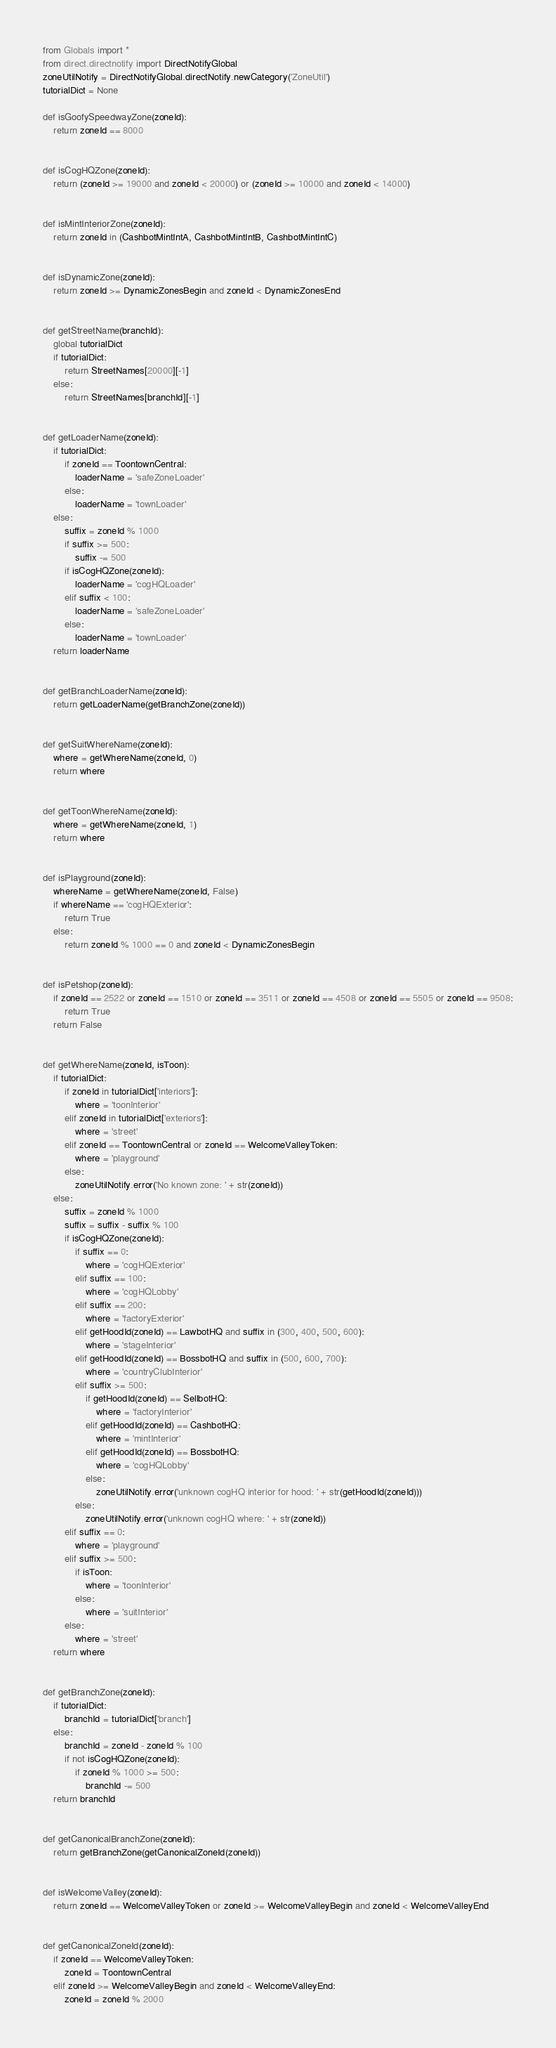Convert code to text. <code><loc_0><loc_0><loc_500><loc_500><_Python_>from Globals import *
from direct.directnotify import DirectNotifyGlobal
zoneUtilNotify = DirectNotifyGlobal.directNotify.newCategory('ZoneUtil')
tutorialDict = None

def isGoofySpeedwayZone(zoneId):
    return zoneId == 8000


def isCogHQZone(zoneId):
    return (zoneId >= 19000 and zoneId < 20000) or (zoneId >= 10000 and zoneId < 14000)


def isMintInteriorZone(zoneId):
    return zoneId in (CashbotMintIntA, CashbotMintIntB, CashbotMintIntC)


def isDynamicZone(zoneId):
    return zoneId >= DynamicZonesBegin and zoneId < DynamicZonesEnd


def getStreetName(branchId):
    global tutorialDict
    if tutorialDict:
        return StreetNames[20000][-1]
    else:
        return StreetNames[branchId][-1]


def getLoaderName(zoneId):
    if tutorialDict:
        if zoneId == ToontownCentral:
            loaderName = 'safeZoneLoader'
        else:
            loaderName = 'townLoader'
    else:
        suffix = zoneId % 1000
        if suffix >= 500:
            suffix -= 500
        if isCogHQZone(zoneId):
            loaderName = 'cogHQLoader'
        elif suffix < 100:
            loaderName = 'safeZoneLoader'
        else:
            loaderName = 'townLoader'
    return loaderName


def getBranchLoaderName(zoneId):
    return getLoaderName(getBranchZone(zoneId))


def getSuitWhereName(zoneId):
    where = getWhereName(zoneId, 0)
    return where


def getToonWhereName(zoneId):
    where = getWhereName(zoneId, 1)
    return where


def isPlayground(zoneId):
    whereName = getWhereName(zoneId, False)
    if whereName == 'cogHQExterior':
        return True
    else:
        return zoneId % 1000 == 0 and zoneId < DynamicZonesBegin


def isPetshop(zoneId):
    if zoneId == 2522 or zoneId == 1510 or zoneId == 3511 or zoneId == 4508 or zoneId == 5505 or zoneId == 9508:
        return True
    return False


def getWhereName(zoneId, isToon):
    if tutorialDict:
        if zoneId in tutorialDict['interiors']:
            where = 'toonInterior'
        elif zoneId in tutorialDict['exteriors']:
            where = 'street'
        elif zoneId == ToontownCentral or zoneId == WelcomeValleyToken:
            where = 'playground'
        else:
            zoneUtilNotify.error('No known zone: ' + str(zoneId))
    else:
        suffix = zoneId % 1000
        suffix = suffix - suffix % 100
        if isCogHQZone(zoneId):
            if suffix == 0:
                where = 'cogHQExterior'
            elif suffix == 100:
                where = 'cogHQLobby'
            elif suffix == 200:
                where = 'factoryExterior'
            elif getHoodId(zoneId) == LawbotHQ and suffix in (300, 400, 500, 600):
                where = 'stageInterior'
            elif getHoodId(zoneId) == BossbotHQ and suffix in (500, 600, 700):
                where = 'countryClubInterior'
            elif suffix >= 500:
                if getHoodId(zoneId) == SellbotHQ:
                    where = 'factoryInterior'
                elif getHoodId(zoneId) == CashbotHQ:
                    where = 'mintInterior'
                elif getHoodId(zoneId) == BossbotHQ:
                    where = 'cogHQLobby'
                else:
                    zoneUtilNotify.error('unknown cogHQ interior for hood: ' + str(getHoodId(zoneId)))
            else:
                zoneUtilNotify.error('unknown cogHQ where: ' + str(zoneId))
        elif suffix == 0:
            where = 'playground'
        elif suffix >= 500:
            if isToon:
                where = 'toonInterior'
            else:
                where = 'suitInterior'
        else:
            where = 'street'
    return where


def getBranchZone(zoneId):
    if tutorialDict:
        branchId = tutorialDict['branch']
    else:
        branchId = zoneId - zoneId % 100
        if not isCogHQZone(zoneId):
            if zoneId % 1000 >= 500:
                branchId -= 500
    return branchId


def getCanonicalBranchZone(zoneId):
    return getBranchZone(getCanonicalZoneId(zoneId))


def isWelcomeValley(zoneId):
    return zoneId == WelcomeValleyToken or zoneId >= WelcomeValleyBegin and zoneId < WelcomeValleyEnd


def getCanonicalZoneId(zoneId):
    if zoneId == WelcomeValleyToken:
        zoneId = ToontownCentral
    elif zoneId >= WelcomeValleyBegin and zoneId < WelcomeValleyEnd:
        zoneId = zoneId % 2000</code> 